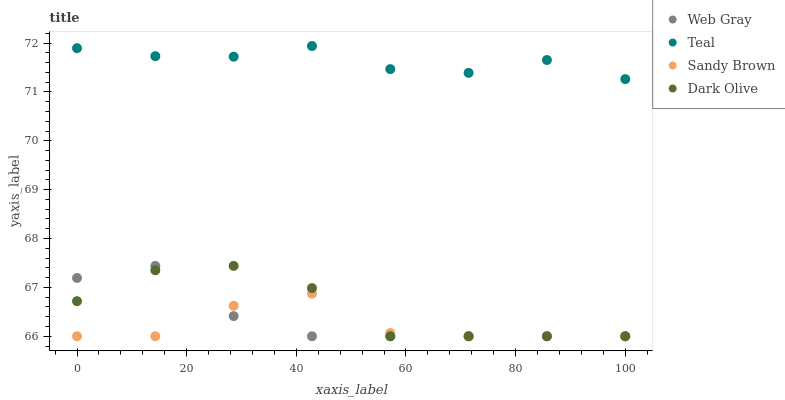Does Sandy Brown have the minimum area under the curve?
Answer yes or no. Yes. Does Teal have the maximum area under the curve?
Answer yes or no. Yes. Does Web Gray have the minimum area under the curve?
Answer yes or no. No. Does Web Gray have the maximum area under the curve?
Answer yes or no. No. Is Web Gray the smoothest?
Answer yes or no. Yes. Is Sandy Brown the roughest?
Answer yes or no. Yes. Is Sandy Brown the smoothest?
Answer yes or no. No. Is Web Gray the roughest?
Answer yes or no. No. Does Dark Olive have the lowest value?
Answer yes or no. Yes. Does Teal have the lowest value?
Answer yes or no. No. Does Teal have the highest value?
Answer yes or no. Yes. Does Web Gray have the highest value?
Answer yes or no. No. Is Web Gray less than Teal?
Answer yes or no. Yes. Is Teal greater than Dark Olive?
Answer yes or no. Yes. Does Dark Olive intersect Web Gray?
Answer yes or no. Yes. Is Dark Olive less than Web Gray?
Answer yes or no. No. Is Dark Olive greater than Web Gray?
Answer yes or no. No. Does Web Gray intersect Teal?
Answer yes or no. No. 